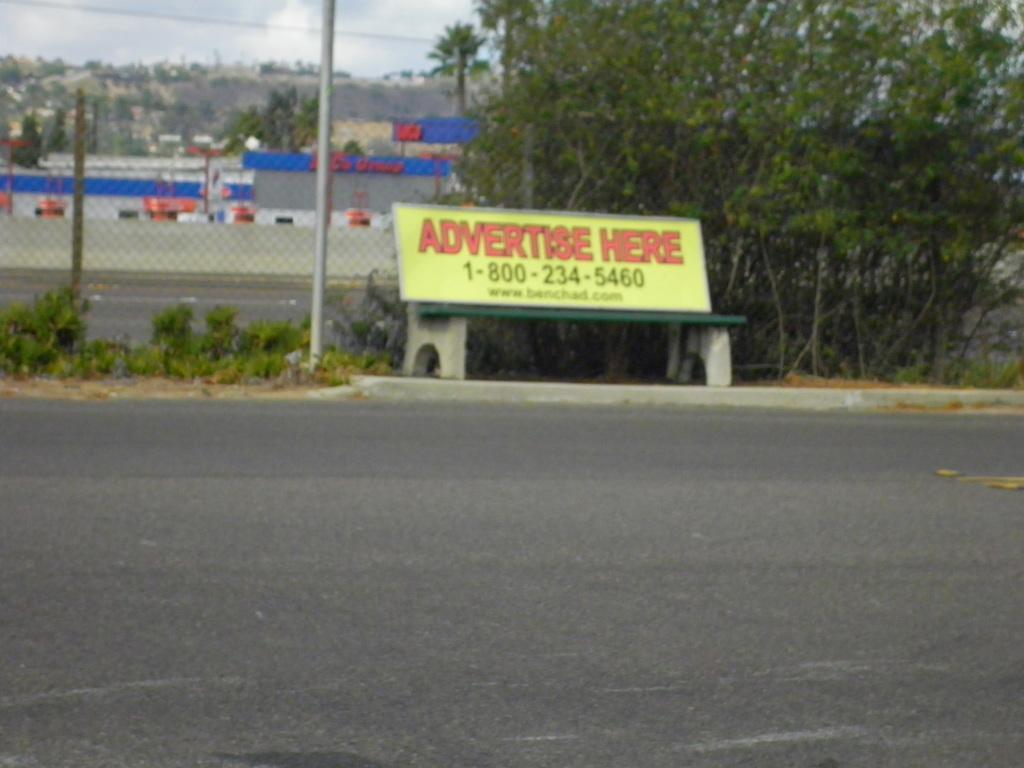Could you give a brief overview of what you see in this image? In the center of the image we can see a bench with some text and numbers placed on the ground. In the background, we can see a fence, building, group of trees and the sky. 